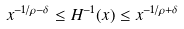Convert formula to latex. <formula><loc_0><loc_0><loc_500><loc_500>x ^ { - 1 / \rho - \delta } \leq H ^ { - 1 } ( x ) \leq x ^ { - 1 / \rho + \delta }</formula> 